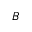Convert formula to latex. <formula><loc_0><loc_0><loc_500><loc_500>_ { B }</formula> 